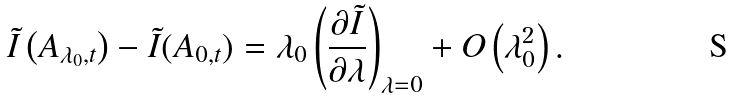Convert formula to latex. <formula><loc_0><loc_0><loc_500><loc_500>\tilde { I } \left ( A _ { \lambda _ { 0 } , t } \right ) - \tilde { I } ( A _ { 0 , t } ) = \lambda _ { 0 } \left ( \frac { \partial \tilde { I } } { \partial \lambda } \right ) _ { \lambda = 0 } + O \left ( \lambda _ { 0 } ^ { 2 } \right ) .</formula> 